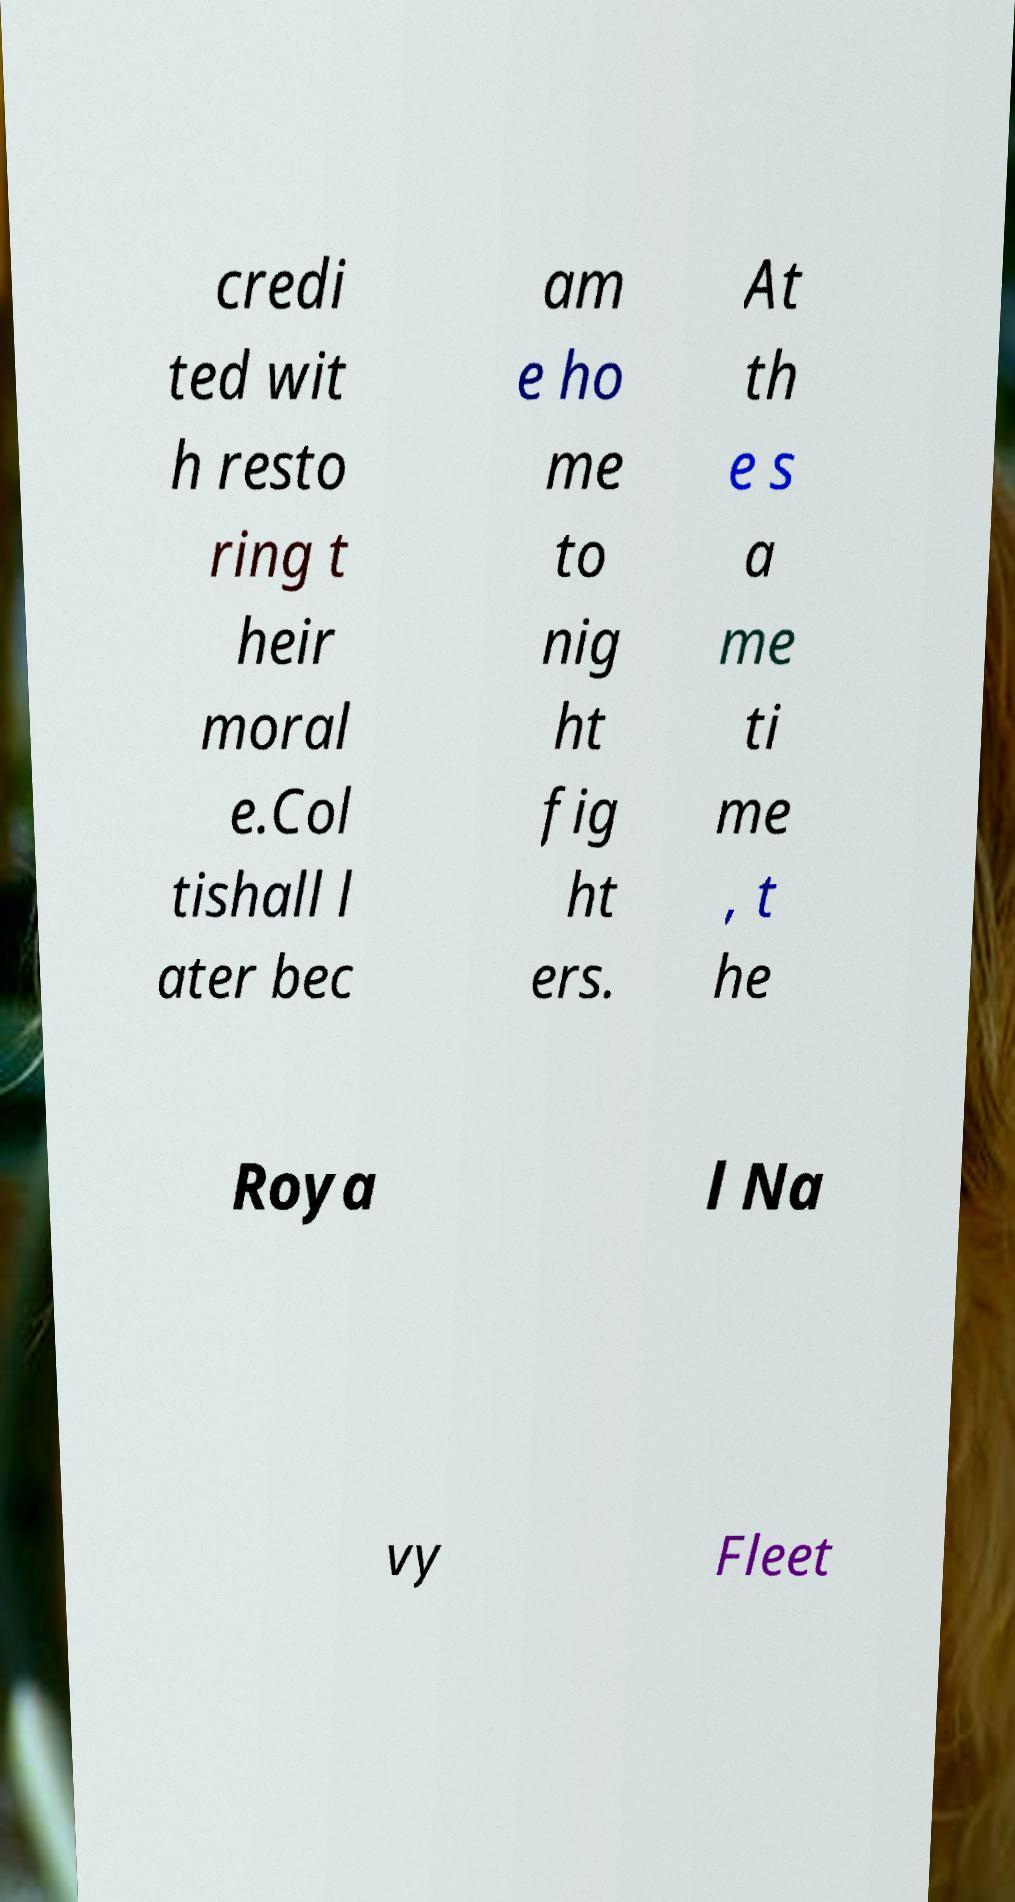Can you read and provide the text displayed in the image?This photo seems to have some interesting text. Can you extract and type it out for me? credi ted wit h resto ring t heir moral e.Col tishall l ater bec am e ho me to nig ht fig ht ers. At th e s a me ti me , t he Roya l Na vy Fleet 